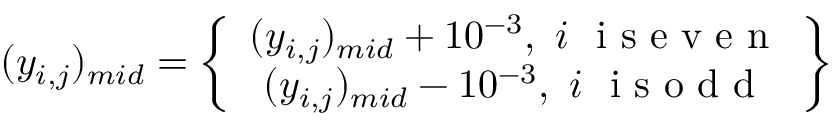<formula> <loc_0><loc_0><loc_500><loc_500>( y _ { i , j } ) _ { m i d } = \left \{ \begin{array} { c } { ( y _ { i , j } ) _ { m i d } + 1 0 ^ { - 3 } , \ i \ i s e v e n } \\ { ( y _ { i , j } ) _ { m i d } - 1 0 ^ { - 3 } , \ i \ i s o d d } \end{array} \right \}</formula> 